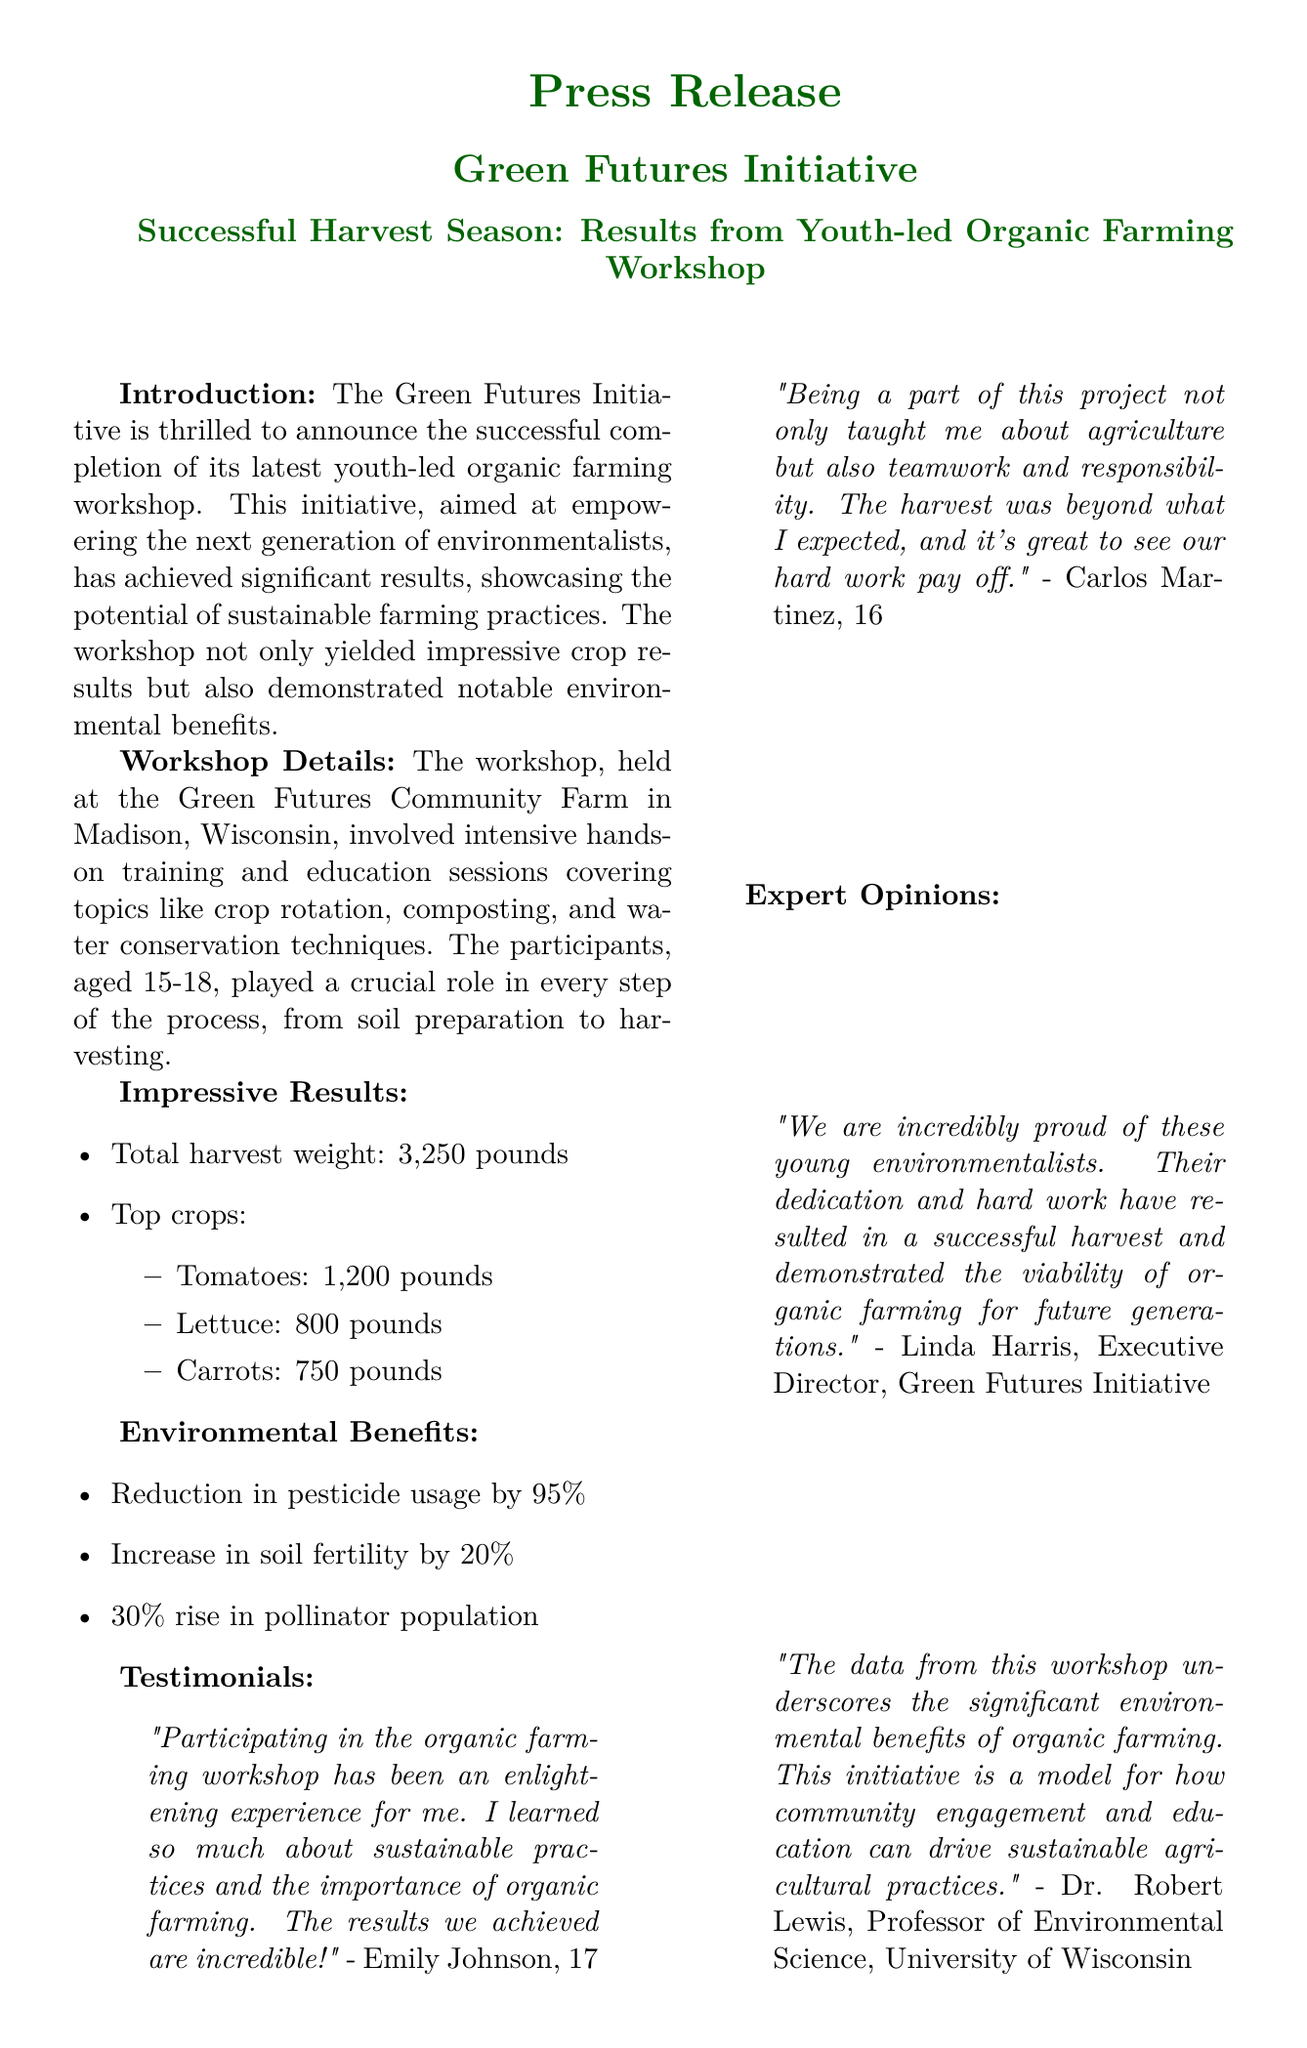What is the total harvest weight? The total harvest weight is found in the results section of the document, which states that the total harvest weight is 3,250 pounds.
Answer: 3,250 pounds Who is the Executive Director of the Green Futures Initiative? The document includes an expert opinion from the Executive Director, Linda Harris, indicating her role and name.
Answer: Linda Harris What percentage reduction in pesticide usage was achieved? The percentage reduction in pesticide usage is mentioned in the environmental benefits section, listed as 95%.
Answer: 95% How many pounds of tomatoes were harvested? The document specifies the weight of the harvest for each top crop, stating that tomatoes weighed 1,200 pounds.
Answer: 1,200 pounds What age range did the participants of the workshop fall into? The introduction describes the age of participants, stating they ranged from 15 to 18 years old.
Answer: 15-18 What environmental benefit saw a 30% increase? The environmental benefits section states a 30% rise in a specific area, which is the pollinator population.
Answer: Pollinator population Which crop had the lowest yield? The results section lists the top crops harvested, with the lowest yield being carrots at 750 pounds.
Answer: Carrots What does the workshop aim to empower? The introduction mentions that the initiative aims to empower the next generation of environmentalists.
Answer: The next generation of environmentalists What is the contact email provided for the Green Futures Initiative? The contact information includes an email address which is found at the bottom of the document.
Answer: info@greenfutures.org 